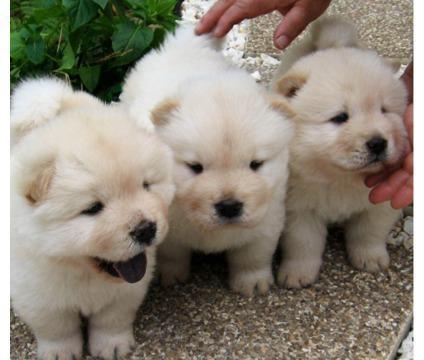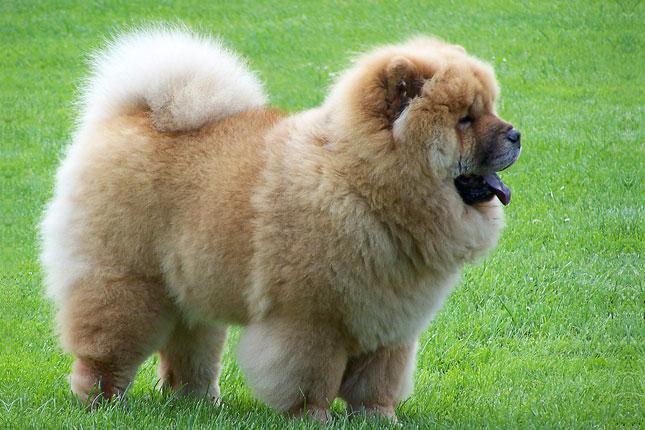The first image is the image on the left, the second image is the image on the right. Evaluate the accuracy of this statement regarding the images: "There is at most 3 dogs.". Is it true? Answer yes or no. No. The first image is the image on the left, the second image is the image on the right. For the images shown, is this caption "There are no more than 3 dogs." true? Answer yes or no. No. 